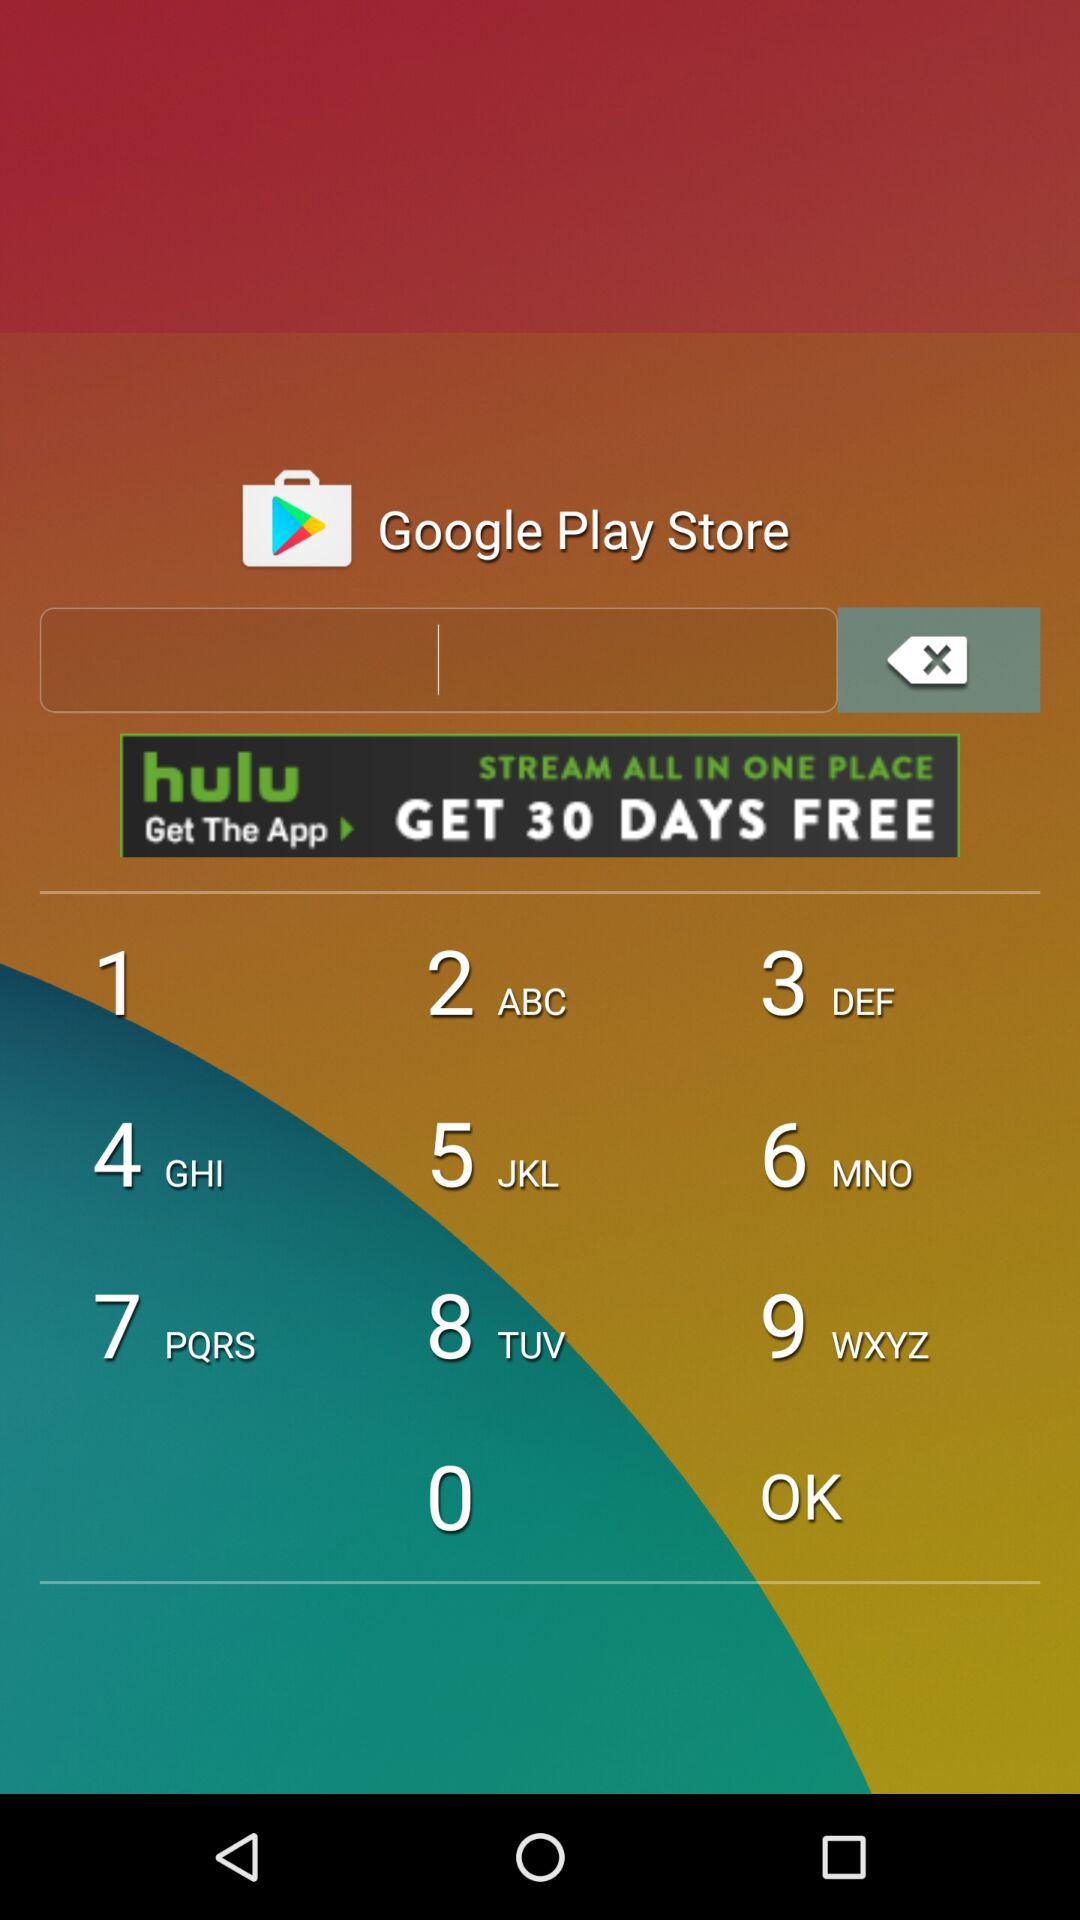How many articles are there in this issue of Discovery Channel India Magazine?
Answer the question using a single word or phrase. 4 